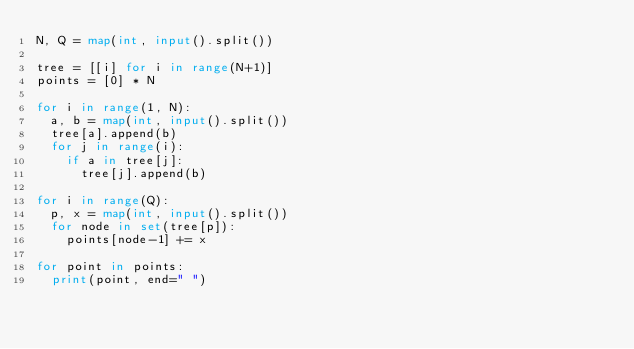Convert code to text. <code><loc_0><loc_0><loc_500><loc_500><_Python_>N, Q = map(int, input().split())

tree = [[i] for i in range(N+1)]
points = [0] * N

for i in range(1, N):
  a, b = map(int, input().split())
  tree[a].append(b)
  for j in range(i):
    if a in tree[j]:
      tree[j].append(b)
      
for i in range(Q):
  p, x = map(int, input().split())
  for node in set(tree[p]):
    points[node-1] += x
    
for point in points:
  print(point, end=" ")</code> 